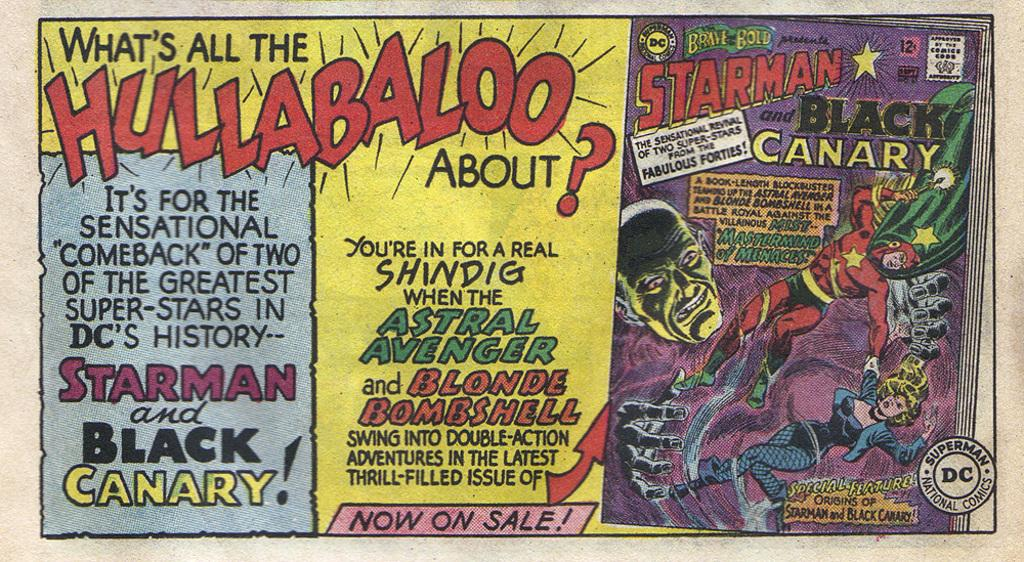What is present in the image that contains visual information? There is a poster in the image. What can be found on the poster besides text? The poster contains images. What can be read on the poster? There is text on the poster. What type of noise can be heard coming from the jail in the image? There is no jail present in the image, and therefore no noise can be heard coming from it. 